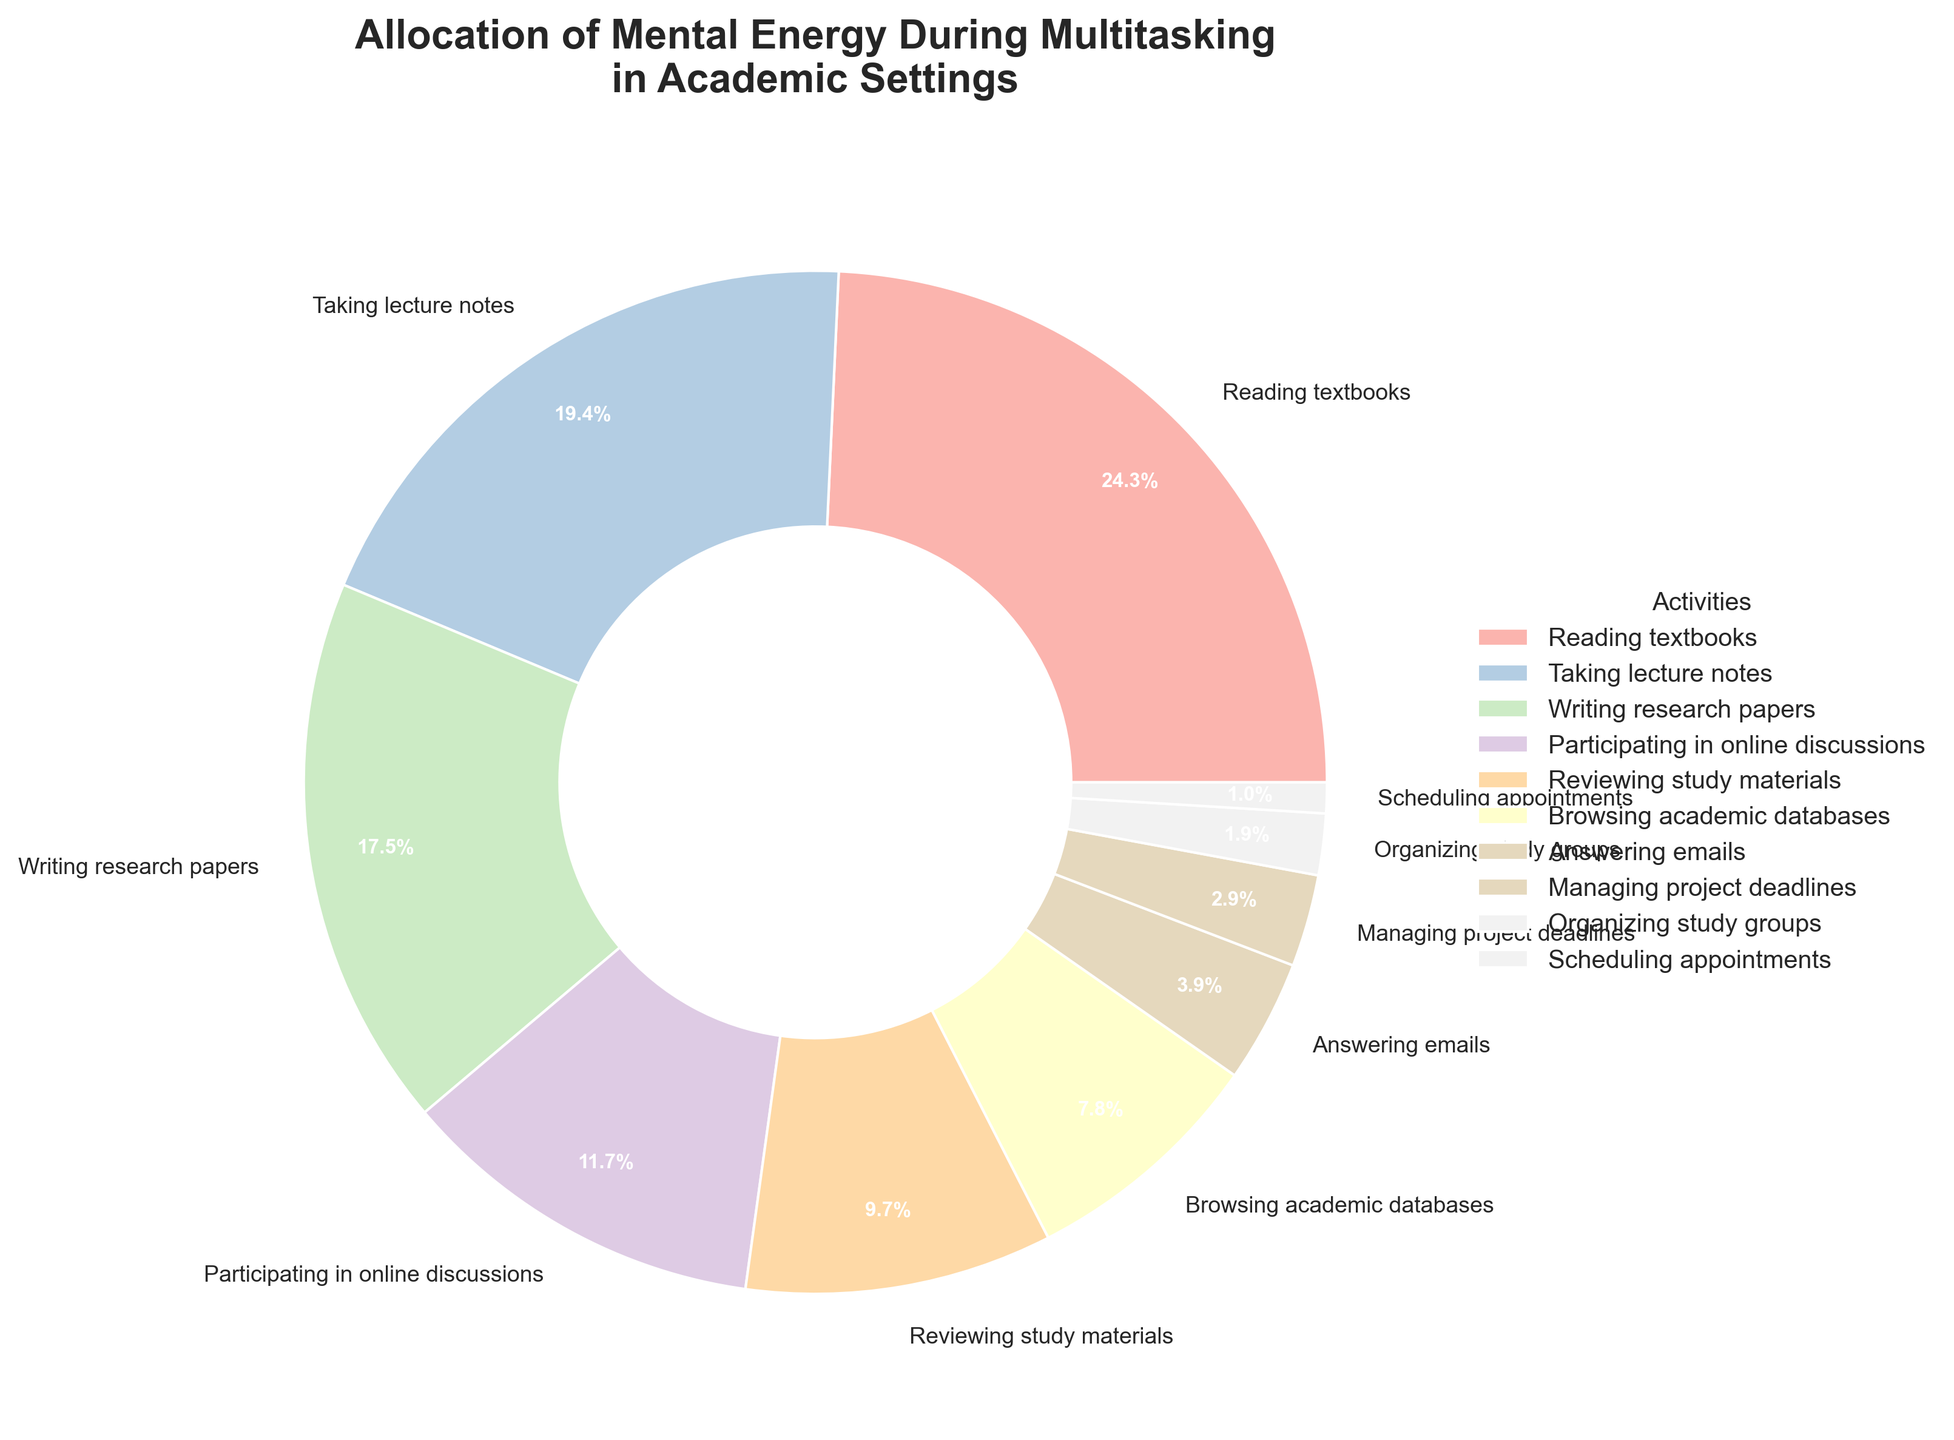What's the total percentage of time spent on activities related to writing (including taking lecture notes and writing research papers)? To find the total percentage, we add the percentages of "Taking Lecture Notes" (20%) and "Writing Research Papers" (18%). Then, we calculate 20% + 18% = 38%.
Answer: 38% Which activity takes up more mental energy: "Participating in online discussions" or "Browsing academic databases"? By looking at the percentages, "Participating in Online Discussions" takes up 12%, whereas "Browsing Academic Databases" takes up 8%. Since 12% is greater than 8%, "Participating in Online Discussions" takes up more mental energy.
Answer: Participating in online discussions What are the top three activities in terms of mental energy allocation? By ordering the activities by percentage, the top three are "Reading Textbooks" (25%), "Taking Lecture Notes" (20%), and "Writing Research Papers" (18%).
Answer: Reading textbooks, taking lecture notes, writing research papers How much more mental energy is allocated to "Reading textbooks" compared to "Answering emails"? "Reading Textbooks" has a percentage of 25%, and "Answering Emails" has a percentage of 4%. The difference is 25% - 4% = 21%.
Answer: 21% What is the total percentage of time spent on activities that are below 10%? We sum up the percentages for the activities below 10%: "Reviewing Study Materials" (10%), "Browsing Academic Databases" (8%), "Answering Emails" (4%), "Managing Project Deadlines" (3%), "Organizing Study Groups" (2%), "Scheduling Appointments" (1%). So, 10% + 8% + 4% + 3% + 2% + 1% = 28%.
Answer: 28% Which activities are represented with the largest and smallest slices in the pie chart? The activity with the largest slice is "Reading Textbooks" at 25%, whereas the smallest slice is for "Scheduling Appointments" at 1%.
Answer: Reading textbooks, scheduling appointments How much mental energy is allocated to "Reviewing study materials" compared to the combined percentage of "Organizing study groups" and "Scheduling appointments"? "Reviewing Study Materials" is allocated 10%, while "Organizing Study Groups" and "Scheduling Appointments" combined are 2% + 1% = 3%. The difference is 10% - 3% = 7%.
Answer: 7% If you ignore the activities taking up 5% or less mental energy, what percentage is left? Activities with 5% or less include "Answering Emails" (4%), "Managing Project Deadlines" (3%), "Organizing Study Groups" (2%), and "Scheduling Appointments" (1%), totaling 10%. Subtract this from 100%, resulting in: 100% - 10% = 90%.
Answer: 90% Which activity's slice is colored in the lightest shade on the pie chart? Visual inspection reveals the activity slice colored in the lightest shade is "Scheduling Appointments".
Answer: Scheduling appointments 